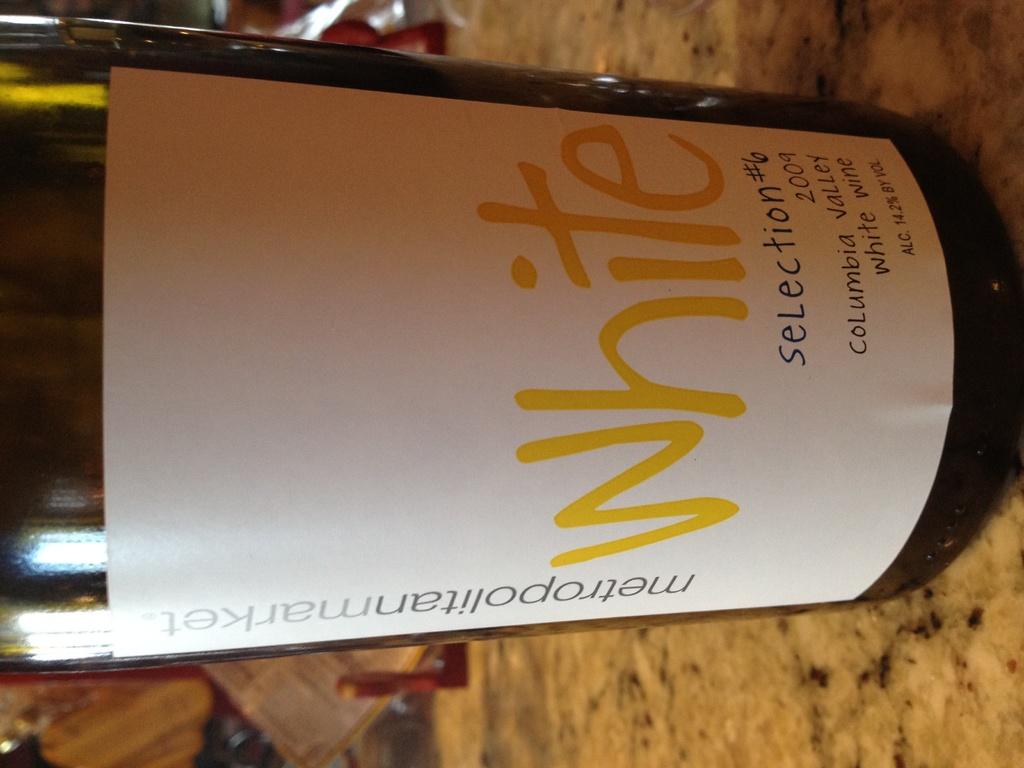What kind of wine is this?
Your answer should be compact. White. What is the vintage of this wine?
Keep it short and to the point. 2009. 